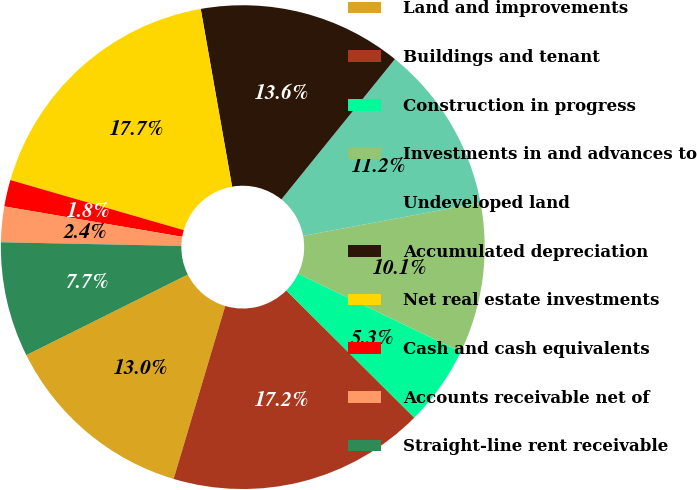<chart> <loc_0><loc_0><loc_500><loc_500><pie_chart><fcel>Land and improvements<fcel>Buildings and tenant<fcel>Construction in progress<fcel>Investments in and advances to<fcel>Undeveloped land<fcel>Accumulated depreciation<fcel>Net real estate investments<fcel>Cash and cash equivalents<fcel>Accounts receivable net of<fcel>Straight-line rent receivable<nl><fcel>13.02%<fcel>17.16%<fcel>5.33%<fcel>10.06%<fcel>11.24%<fcel>13.61%<fcel>17.75%<fcel>1.78%<fcel>2.37%<fcel>7.69%<nl></chart> 